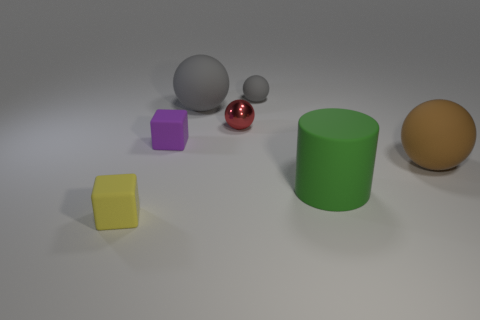There is another small object that is the same shape as the small metal thing; what is its color?
Offer a very short reply. Gray. How many objects are either brown rubber objects or large gray rubber objects?
Provide a succinct answer. 2. What shape is the big brown thing that is made of the same material as the tiny gray object?
Give a very brief answer. Sphere. What number of big things are either brown cylinders or matte spheres?
Ensure brevity in your answer.  2. How many other objects are there of the same color as the cylinder?
Your answer should be compact. 0. How many tiny yellow blocks are behind the tiny rubber block behind the rubber cube in front of the big brown rubber sphere?
Keep it short and to the point. 0. There is a matte block in front of the brown ball; does it have the same size as the tiny gray matte sphere?
Give a very brief answer. Yes. Is the number of purple objects to the right of the big green cylinder less than the number of gray rubber spheres that are in front of the small gray rubber sphere?
Offer a terse response. Yes. Is the number of green rubber objects in front of the tiny purple rubber cube less than the number of cubes?
Provide a short and direct response. Yes. There is another sphere that is the same color as the small matte sphere; what material is it?
Your answer should be very brief. Rubber. 